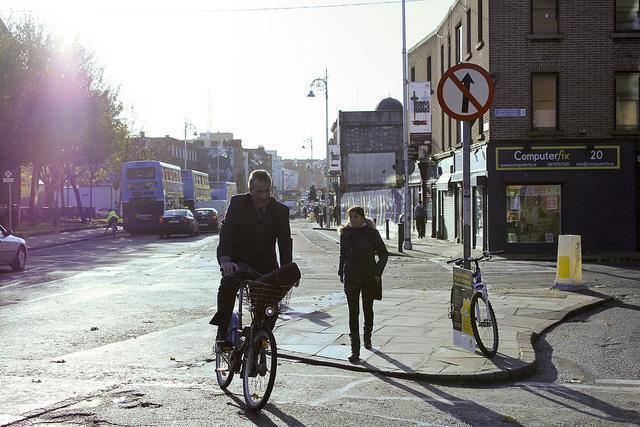Where is the man on the bicycle possibly going?
Make your selection from the four choices given to correctly answer the question.
Options: Work, school, gym, wedding. Work. 